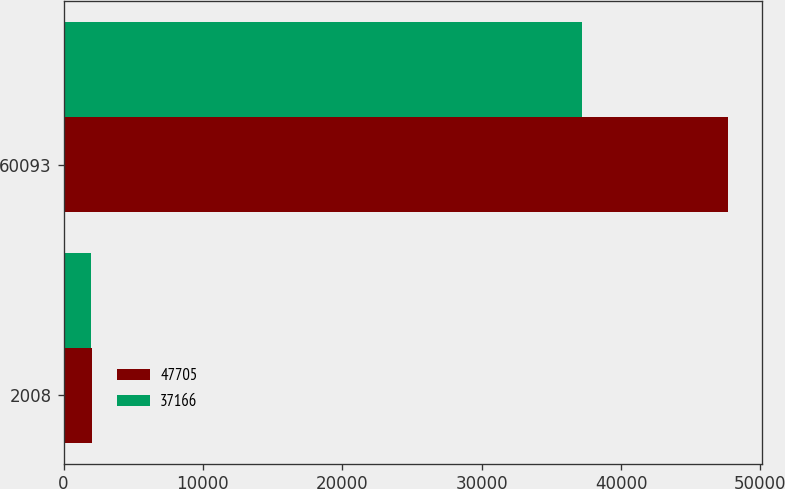Convert chart. <chart><loc_0><loc_0><loc_500><loc_500><stacked_bar_chart><ecel><fcel>2008<fcel>60093<nl><fcel>47705<fcel>2007<fcel>47705<nl><fcel>37166<fcel>2006<fcel>37166<nl></chart> 